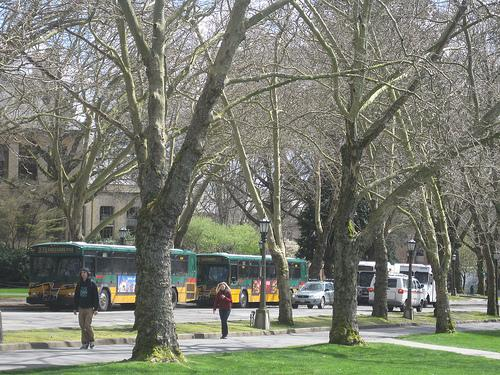Question: what is parked on the street?
Choices:
A. Cars.
B. Buses.
C. Motorcycles.
D. Bicycles.
Answer with the letter. Answer: B Question: what color are the trees?
Choices:
A. Brown.
B. Green.
C. Dark brown.
D. White.
Answer with the letter. Answer: A Question: who is wearing a red shirt?
Choices:
A. The boy.
B. The woman.
C. The man.
D. The young girl.
Answer with the letter. Answer: B Question: when was this photo taken?
Choices:
A. During the day.
B. Midnight.
C. Sunrise.
D. Sunset.
Answer with the letter. Answer: A 